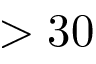Convert formula to latex. <formula><loc_0><loc_0><loc_500><loc_500>> 3 0</formula> 